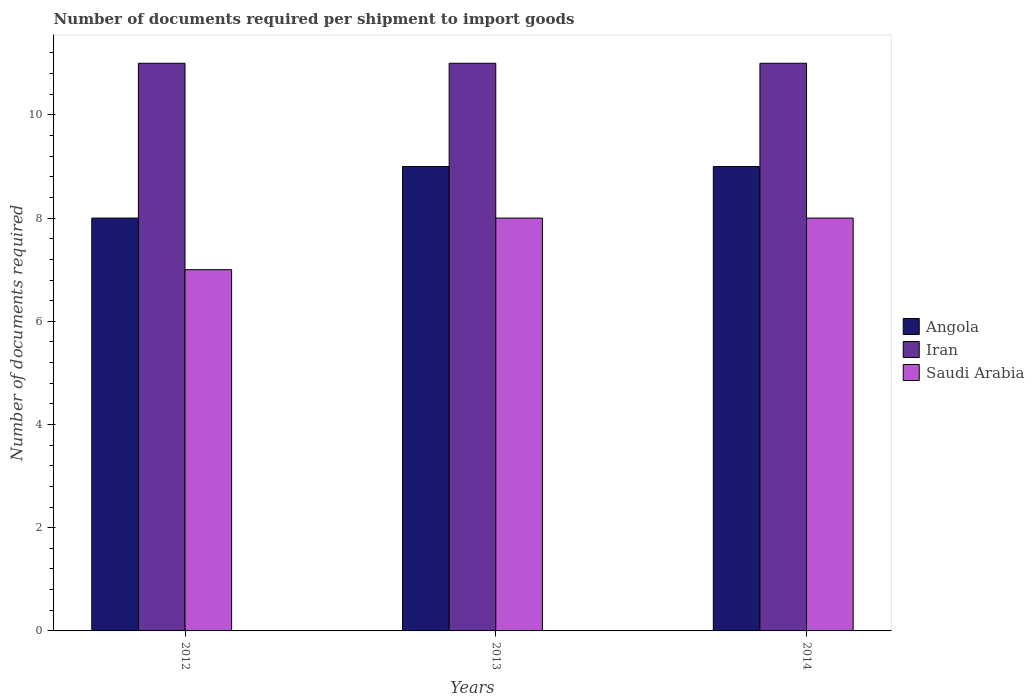Are the number of bars per tick equal to the number of legend labels?
Your response must be concise. Yes. How many bars are there on the 1st tick from the left?
Your response must be concise. 3. How many bars are there on the 1st tick from the right?
Keep it short and to the point. 3. What is the number of documents required per shipment to import goods in Angola in 2012?
Ensure brevity in your answer.  8. Across all years, what is the maximum number of documents required per shipment to import goods in Iran?
Provide a short and direct response. 11. Across all years, what is the minimum number of documents required per shipment to import goods in Angola?
Make the answer very short. 8. In which year was the number of documents required per shipment to import goods in Angola maximum?
Your response must be concise. 2013. What is the total number of documents required per shipment to import goods in Iran in the graph?
Your answer should be compact. 33. What is the difference between the number of documents required per shipment to import goods in Saudi Arabia in 2012 and that in 2014?
Provide a succinct answer. -1. What is the difference between the number of documents required per shipment to import goods in Saudi Arabia in 2014 and the number of documents required per shipment to import goods in Iran in 2013?
Keep it short and to the point. -3. What is the average number of documents required per shipment to import goods in Angola per year?
Offer a terse response. 8.67. In the year 2013, what is the difference between the number of documents required per shipment to import goods in Saudi Arabia and number of documents required per shipment to import goods in Iran?
Your answer should be very brief. -3. In how many years, is the number of documents required per shipment to import goods in Saudi Arabia greater than 8.8?
Offer a terse response. 0. What is the ratio of the number of documents required per shipment to import goods in Angola in 2013 to that in 2014?
Give a very brief answer. 1. Is the difference between the number of documents required per shipment to import goods in Saudi Arabia in 2012 and 2014 greater than the difference between the number of documents required per shipment to import goods in Iran in 2012 and 2014?
Ensure brevity in your answer.  No. What is the difference between the highest and the lowest number of documents required per shipment to import goods in Angola?
Provide a succinct answer. 1. In how many years, is the number of documents required per shipment to import goods in Iran greater than the average number of documents required per shipment to import goods in Iran taken over all years?
Ensure brevity in your answer.  0. What does the 3rd bar from the left in 2012 represents?
Your response must be concise. Saudi Arabia. What does the 1st bar from the right in 2013 represents?
Offer a very short reply. Saudi Arabia. Is it the case that in every year, the sum of the number of documents required per shipment to import goods in Iran and number of documents required per shipment to import goods in Saudi Arabia is greater than the number of documents required per shipment to import goods in Angola?
Offer a very short reply. Yes. Are all the bars in the graph horizontal?
Offer a terse response. No. What is the difference between two consecutive major ticks on the Y-axis?
Provide a short and direct response. 2. Are the values on the major ticks of Y-axis written in scientific E-notation?
Provide a succinct answer. No. Does the graph contain any zero values?
Offer a terse response. No. Does the graph contain grids?
Offer a terse response. No. How many legend labels are there?
Provide a succinct answer. 3. How are the legend labels stacked?
Give a very brief answer. Vertical. What is the title of the graph?
Provide a short and direct response. Number of documents required per shipment to import goods. What is the label or title of the X-axis?
Provide a succinct answer. Years. What is the label or title of the Y-axis?
Offer a very short reply. Number of documents required. What is the Number of documents required of Iran in 2012?
Offer a terse response. 11. What is the Number of documents required of Angola in 2013?
Offer a terse response. 9. What is the Number of documents required in Iran in 2013?
Provide a succinct answer. 11. What is the Number of documents required of Saudi Arabia in 2013?
Provide a succinct answer. 8. What is the Number of documents required in Angola in 2014?
Give a very brief answer. 9. What is the Number of documents required of Iran in 2014?
Your answer should be compact. 11. Across all years, what is the maximum Number of documents required in Saudi Arabia?
Ensure brevity in your answer.  8. What is the total Number of documents required of Angola in the graph?
Provide a succinct answer. 26. What is the total Number of documents required in Saudi Arabia in the graph?
Make the answer very short. 23. What is the difference between the Number of documents required in Saudi Arabia in 2012 and that in 2013?
Your response must be concise. -1. What is the difference between the Number of documents required of Iran in 2013 and that in 2014?
Ensure brevity in your answer.  0. What is the difference between the Number of documents required in Angola in 2012 and the Number of documents required in Iran in 2014?
Offer a terse response. -3. What is the difference between the Number of documents required of Angola in 2012 and the Number of documents required of Saudi Arabia in 2014?
Your response must be concise. 0. What is the difference between the Number of documents required in Iran in 2012 and the Number of documents required in Saudi Arabia in 2014?
Provide a short and direct response. 3. What is the difference between the Number of documents required in Angola in 2013 and the Number of documents required in Iran in 2014?
Offer a very short reply. -2. What is the difference between the Number of documents required of Iran in 2013 and the Number of documents required of Saudi Arabia in 2014?
Keep it short and to the point. 3. What is the average Number of documents required of Angola per year?
Ensure brevity in your answer.  8.67. What is the average Number of documents required in Iran per year?
Keep it short and to the point. 11. What is the average Number of documents required of Saudi Arabia per year?
Provide a succinct answer. 7.67. In the year 2012, what is the difference between the Number of documents required in Angola and Number of documents required in Iran?
Your response must be concise. -3. In the year 2012, what is the difference between the Number of documents required in Iran and Number of documents required in Saudi Arabia?
Provide a short and direct response. 4. In the year 2013, what is the difference between the Number of documents required of Angola and Number of documents required of Saudi Arabia?
Make the answer very short. 1. What is the ratio of the Number of documents required in Iran in 2012 to that in 2013?
Your answer should be compact. 1. What is the ratio of the Number of documents required of Saudi Arabia in 2012 to that in 2013?
Your answer should be very brief. 0.88. What is the ratio of the Number of documents required of Angola in 2012 to that in 2014?
Your answer should be very brief. 0.89. What is the ratio of the Number of documents required of Iran in 2012 to that in 2014?
Keep it short and to the point. 1. What is the ratio of the Number of documents required in Iran in 2013 to that in 2014?
Your answer should be compact. 1. What is the difference between the highest and the lowest Number of documents required in Angola?
Provide a succinct answer. 1. What is the difference between the highest and the lowest Number of documents required in Iran?
Make the answer very short. 0. What is the difference between the highest and the lowest Number of documents required of Saudi Arabia?
Offer a very short reply. 1. 